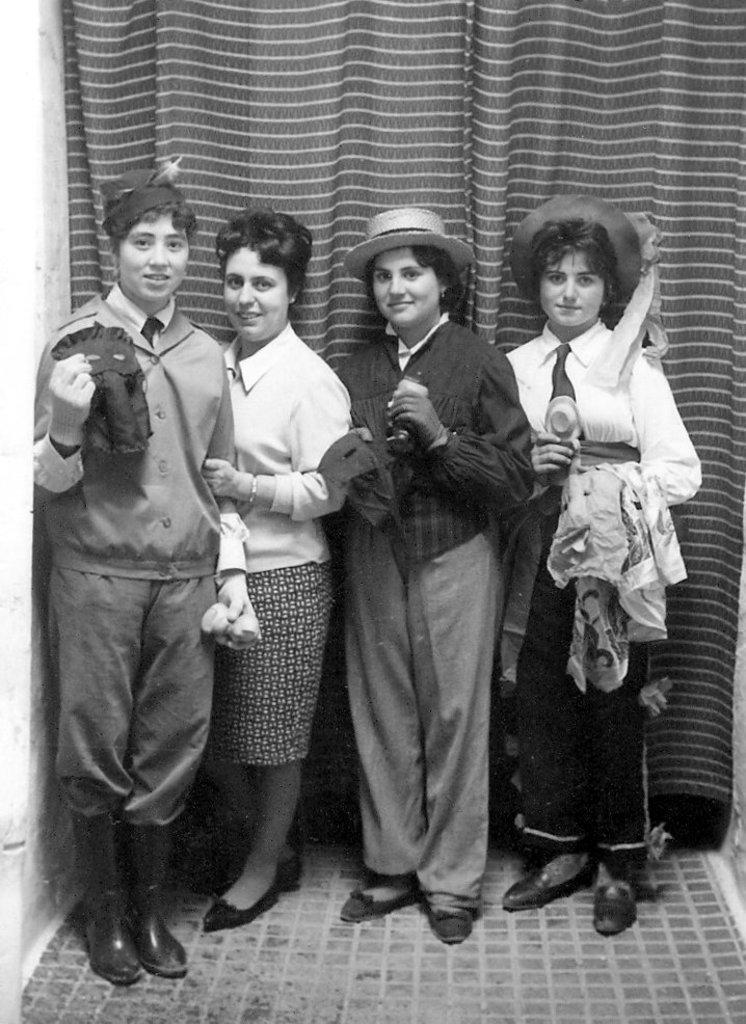How many people are in the image? There are four people in the image. What are the people doing in the image? The people are standing, seeing, and smiling. Are any of the people holding objects? Yes, some people are holding objects. What can be seen on the left side of the image? There is a wall on the left side of the image. What is present in the background of the image? There is a curtain in the background of the image. What type of knee injury can be seen on the person in the image? There is no knee injury visible in the image; the people are standing and appear to be in good health. What appliance is being used by the people in the image? There is no appliance visible in the image; the people are simply standing and holding objects. 